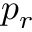Convert formula to latex. <formula><loc_0><loc_0><loc_500><loc_500>p _ { r }</formula> 